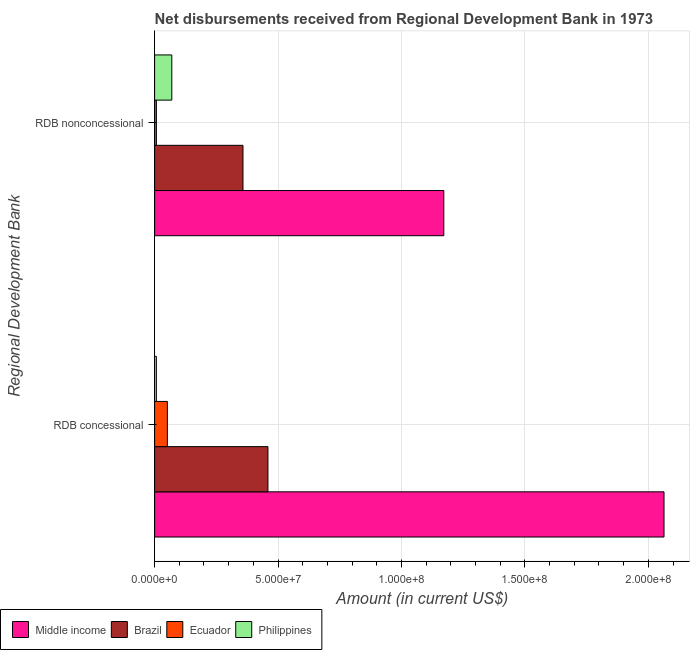How many groups of bars are there?
Provide a succinct answer. 2. How many bars are there on the 1st tick from the top?
Your answer should be very brief. 4. What is the label of the 1st group of bars from the top?
Your response must be concise. RDB nonconcessional. What is the net non concessional disbursements from rdb in Brazil?
Ensure brevity in your answer.  3.58e+07. Across all countries, what is the maximum net concessional disbursements from rdb?
Give a very brief answer. 2.06e+08. Across all countries, what is the minimum net concessional disbursements from rdb?
Ensure brevity in your answer.  7.12e+05. What is the total net non concessional disbursements from rdb in the graph?
Your response must be concise. 1.61e+08. What is the difference between the net non concessional disbursements from rdb in Philippines and that in Middle income?
Make the answer very short. -1.10e+08. What is the difference between the net non concessional disbursements from rdb in Middle income and the net concessional disbursements from rdb in Philippines?
Keep it short and to the point. 1.16e+08. What is the average net concessional disbursements from rdb per country?
Ensure brevity in your answer.  6.45e+07. What is the difference between the net non concessional disbursements from rdb and net concessional disbursements from rdb in Philippines?
Provide a short and direct response. 6.25e+06. In how many countries, is the net non concessional disbursements from rdb greater than 170000000 US$?
Your response must be concise. 0. What is the ratio of the net non concessional disbursements from rdb in Ecuador to that in Philippines?
Ensure brevity in your answer.  0.1. Is the net concessional disbursements from rdb in Brazil less than that in Ecuador?
Provide a short and direct response. No. In how many countries, is the net non concessional disbursements from rdb greater than the average net non concessional disbursements from rdb taken over all countries?
Offer a terse response. 1. What does the 2nd bar from the bottom in RDB concessional represents?
Keep it short and to the point. Brazil. How many bars are there?
Provide a succinct answer. 8. Are the values on the major ticks of X-axis written in scientific E-notation?
Provide a short and direct response. Yes. Does the graph contain grids?
Ensure brevity in your answer.  Yes. Where does the legend appear in the graph?
Offer a very short reply. Bottom left. How many legend labels are there?
Your answer should be very brief. 4. How are the legend labels stacked?
Give a very brief answer. Horizontal. What is the title of the graph?
Keep it short and to the point. Net disbursements received from Regional Development Bank in 1973. Does "Least developed countries" appear as one of the legend labels in the graph?
Keep it short and to the point. No. What is the label or title of the X-axis?
Your answer should be compact. Amount (in current US$). What is the label or title of the Y-axis?
Give a very brief answer. Regional Development Bank. What is the Amount (in current US$) in Middle income in RDB concessional?
Offer a very short reply. 2.06e+08. What is the Amount (in current US$) of Brazil in RDB concessional?
Offer a very short reply. 4.59e+07. What is the Amount (in current US$) of Ecuador in RDB concessional?
Offer a very short reply. 5.17e+06. What is the Amount (in current US$) of Philippines in RDB concessional?
Give a very brief answer. 7.12e+05. What is the Amount (in current US$) of Middle income in RDB nonconcessional?
Your response must be concise. 1.17e+08. What is the Amount (in current US$) of Brazil in RDB nonconcessional?
Your answer should be very brief. 3.58e+07. What is the Amount (in current US$) in Ecuador in RDB nonconcessional?
Your response must be concise. 7.26e+05. What is the Amount (in current US$) in Philippines in RDB nonconcessional?
Your response must be concise. 6.96e+06. Across all Regional Development Bank, what is the maximum Amount (in current US$) in Middle income?
Provide a short and direct response. 2.06e+08. Across all Regional Development Bank, what is the maximum Amount (in current US$) in Brazil?
Make the answer very short. 4.59e+07. Across all Regional Development Bank, what is the maximum Amount (in current US$) of Ecuador?
Offer a very short reply. 5.17e+06. Across all Regional Development Bank, what is the maximum Amount (in current US$) of Philippines?
Your answer should be compact. 6.96e+06. Across all Regional Development Bank, what is the minimum Amount (in current US$) of Middle income?
Offer a terse response. 1.17e+08. Across all Regional Development Bank, what is the minimum Amount (in current US$) of Brazil?
Your answer should be compact. 3.58e+07. Across all Regional Development Bank, what is the minimum Amount (in current US$) in Ecuador?
Make the answer very short. 7.26e+05. Across all Regional Development Bank, what is the minimum Amount (in current US$) of Philippines?
Provide a short and direct response. 7.12e+05. What is the total Amount (in current US$) in Middle income in the graph?
Your answer should be very brief. 3.23e+08. What is the total Amount (in current US$) of Brazil in the graph?
Offer a terse response. 8.17e+07. What is the total Amount (in current US$) in Ecuador in the graph?
Ensure brevity in your answer.  5.89e+06. What is the total Amount (in current US$) of Philippines in the graph?
Ensure brevity in your answer.  7.67e+06. What is the difference between the Amount (in current US$) of Middle income in RDB concessional and that in RDB nonconcessional?
Provide a succinct answer. 8.92e+07. What is the difference between the Amount (in current US$) in Brazil in RDB concessional and that in RDB nonconcessional?
Make the answer very short. 1.01e+07. What is the difference between the Amount (in current US$) in Ecuador in RDB concessional and that in RDB nonconcessional?
Provide a succinct answer. 4.44e+06. What is the difference between the Amount (in current US$) of Philippines in RDB concessional and that in RDB nonconcessional?
Make the answer very short. -6.25e+06. What is the difference between the Amount (in current US$) in Middle income in RDB concessional and the Amount (in current US$) in Brazil in RDB nonconcessional?
Offer a very short reply. 1.71e+08. What is the difference between the Amount (in current US$) in Middle income in RDB concessional and the Amount (in current US$) in Ecuador in RDB nonconcessional?
Offer a very short reply. 2.06e+08. What is the difference between the Amount (in current US$) in Middle income in RDB concessional and the Amount (in current US$) in Philippines in RDB nonconcessional?
Your answer should be compact. 1.99e+08. What is the difference between the Amount (in current US$) in Brazil in RDB concessional and the Amount (in current US$) in Ecuador in RDB nonconcessional?
Give a very brief answer. 4.52e+07. What is the difference between the Amount (in current US$) in Brazil in RDB concessional and the Amount (in current US$) in Philippines in RDB nonconcessional?
Offer a terse response. 3.89e+07. What is the difference between the Amount (in current US$) in Ecuador in RDB concessional and the Amount (in current US$) in Philippines in RDB nonconcessional?
Ensure brevity in your answer.  -1.80e+06. What is the average Amount (in current US$) of Middle income per Regional Development Bank?
Your answer should be very brief. 1.62e+08. What is the average Amount (in current US$) of Brazil per Regional Development Bank?
Your answer should be very brief. 4.09e+07. What is the average Amount (in current US$) in Ecuador per Regional Development Bank?
Your response must be concise. 2.95e+06. What is the average Amount (in current US$) of Philippines per Regional Development Bank?
Provide a succinct answer. 3.84e+06. What is the difference between the Amount (in current US$) in Middle income and Amount (in current US$) in Brazil in RDB concessional?
Give a very brief answer. 1.60e+08. What is the difference between the Amount (in current US$) of Middle income and Amount (in current US$) of Ecuador in RDB concessional?
Give a very brief answer. 2.01e+08. What is the difference between the Amount (in current US$) in Middle income and Amount (in current US$) in Philippines in RDB concessional?
Your answer should be compact. 2.06e+08. What is the difference between the Amount (in current US$) of Brazil and Amount (in current US$) of Ecuador in RDB concessional?
Make the answer very short. 4.07e+07. What is the difference between the Amount (in current US$) of Brazil and Amount (in current US$) of Philippines in RDB concessional?
Offer a terse response. 4.52e+07. What is the difference between the Amount (in current US$) in Ecuador and Amount (in current US$) in Philippines in RDB concessional?
Ensure brevity in your answer.  4.46e+06. What is the difference between the Amount (in current US$) of Middle income and Amount (in current US$) of Brazil in RDB nonconcessional?
Your answer should be very brief. 8.13e+07. What is the difference between the Amount (in current US$) in Middle income and Amount (in current US$) in Ecuador in RDB nonconcessional?
Your answer should be very brief. 1.16e+08. What is the difference between the Amount (in current US$) of Middle income and Amount (in current US$) of Philippines in RDB nonconcessional?
Your response must be concise. 1.10e+08. What is the difference between the Amount (in current US$) of Brazil and Amount (in current US$) of Ecuador in RDB nonconcessional?
Make the answer very short. 3.51e+07. What is the difference between the Amount (in current US$) in Brazil and Amount (in current US$) in Philippines in RDB nonconcessional?
Keep it short and to the point. 2.88e+07. What is the difference between the Amount (in current US$) of Ecuador and Amount (in current US$) of Philippines in RDB nonconcessional?
Your answer should be very brief. -6.24e+06. What is the ratio of the Amount (in current US$) of Middle income in RDB concessional to that in RDB nonconcessional?
Offer a terse response. 1.76. What is the ratio of the Amount (in current US$) in Brazil in RDB concessional to that in RDB nonconcessional?
Your response must be concise. 1.28. What is the ratio of the Amount (in current US$) of Ecuador in RDB concessional to that in RDB nonconcessional?
Provide a succinct answer. 7.12. What is the ratio of the Amount (in current US$) of Philippines in RDB concessional to that in RDB nonconcessional?
Your answer should be compact. 0.1. What is the difference between the highest and the second highest Amount (in current US$) of Middle income?
Give a very brief answer. 8.92e+07. What is the difference between the highest and the second highest Amount (in current US$) in Brazil?
Offer a very short reply. 1.01e+07. What is the difference between the highest and the second highest Amount (in current US$) of Ecuador?
Provide a succinct answer. 4.44e+06. What is the difference between the highest and the second highest Amount (in current US$) of Philippines?
Your answer should be compact. 6.25e+06. What is the difference between the highest and the lowest Amount (in current US$) in Middle income?
Offer a terse response. 8.92e+07. What is the difference between the highest and the lowest Amount (in current US$) in Brazil?
Give a very brief answer. 1.01e+07. What is the difference between the highest and the lowest Amount (in current US$) of Ecuador?
Your answer should be compact. 4.44e+06. What is the difference between the highest and the lowest Amount (in current US$) in Philippines?
Provide a short and direct response. 6.25e+06. 